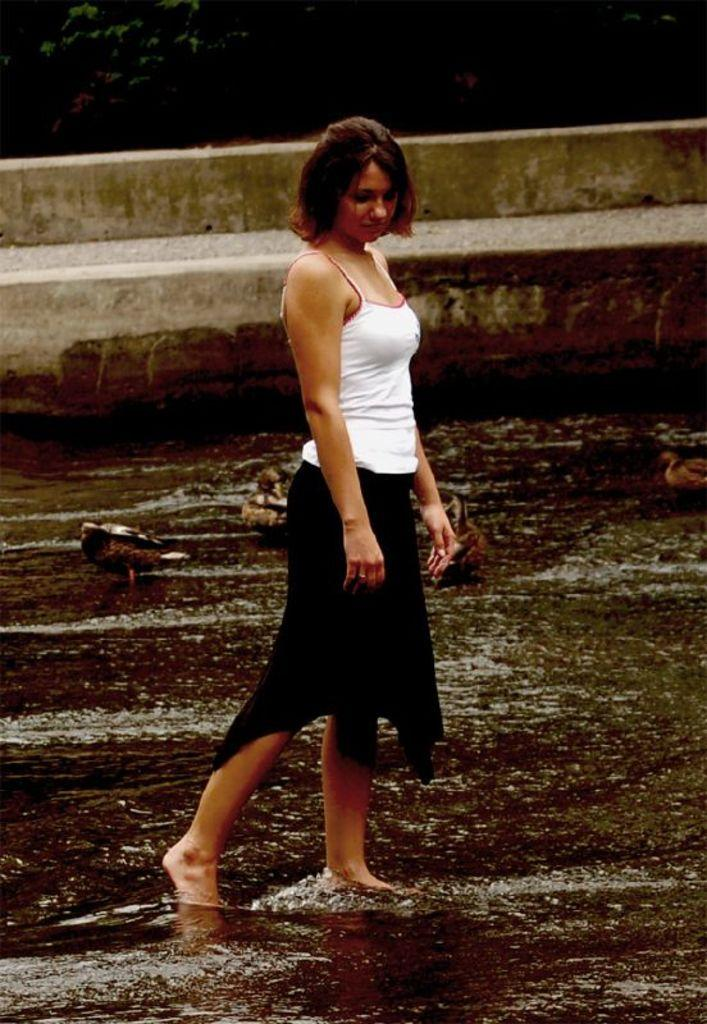What is the lady doing in the image? The lady is standing on the water in the image. What else can be seen in the water in the image? There are birds in the water in the image. Can you describe any structures or objects in the image? Yes, there is a small wall visible in the image. What type of suit is the baby wearing in the image? There is no baby present in the image, so it is not possible to determine what type of suit they might be wearing. 